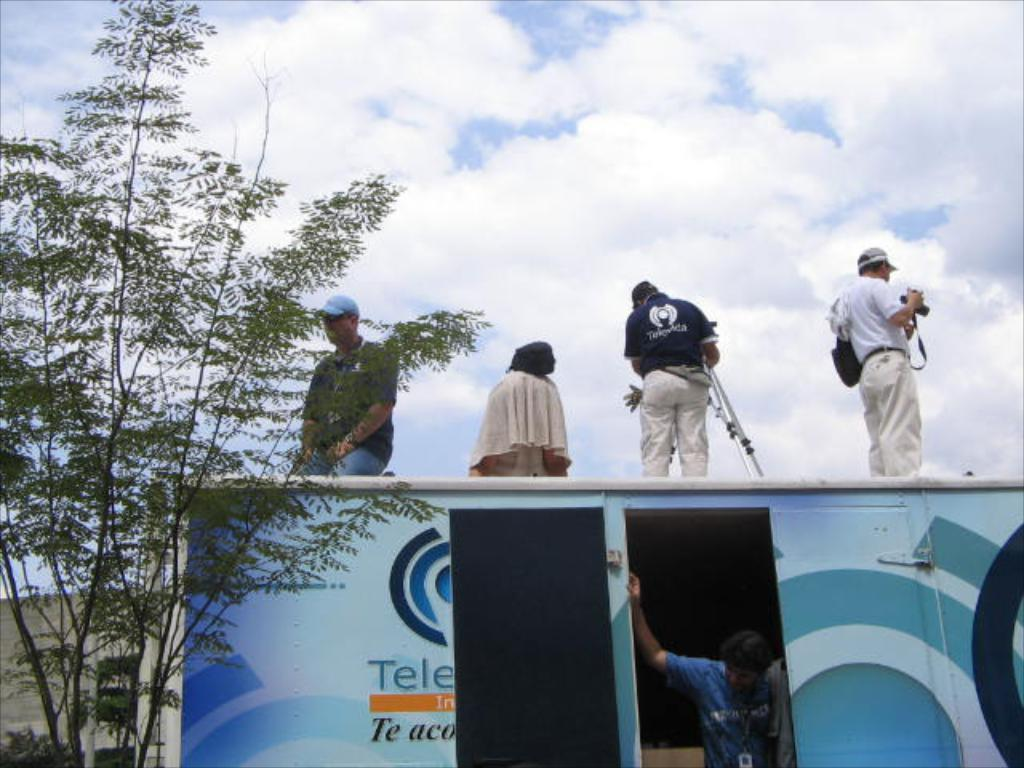What is the main subject of the image? The main subject of the image is people on a vehicle. Can you describe the people in the vehicle? There is a person inside the vehicle, and there are people on the vehicle. What can be seen in the background of the image? Trees and the sky with clouds are visible in the background of the image. What type of operation is being performed on the notebook in the image? There is no notebook present in the image. 